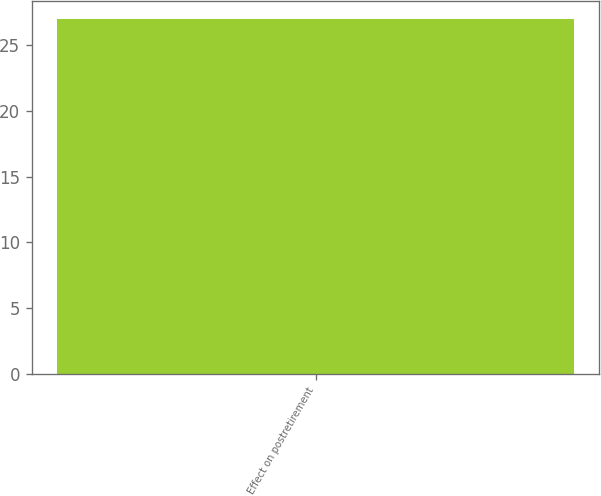<chart> <loc_0><loc_0><loc_500><loc_500><bar_chart><fcel>Effect on postretirement<nl><fcel>27<nl></chart> 